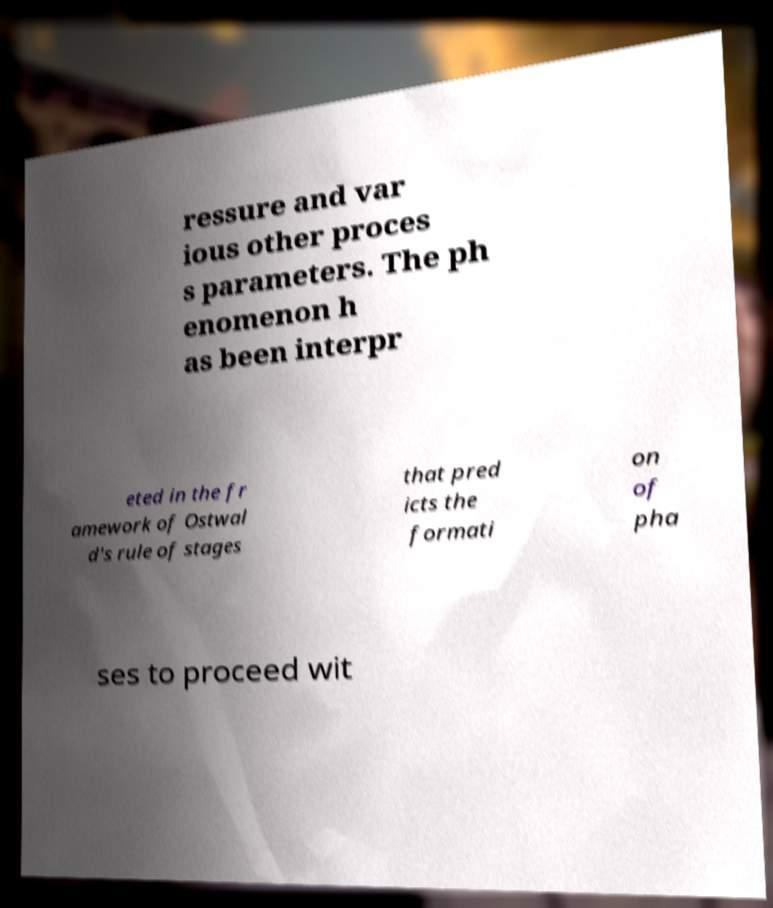I need the written content from this picture converted into text. Can you do that? ressure and var ious other proces s parameters. The ph enomenon h as been interpr eted in the fr amework of Ostwal d's rule of stages that pred icts the formati on of pha ses to proceed wit 